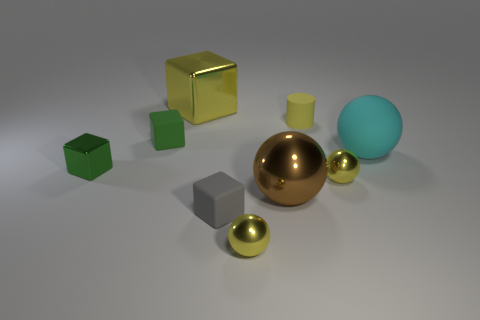Subtract 1 blocks. How many blocks are left? 3 Subtract all cyan spheres. How many spheres are left? 3 Subtract all large cyan spheres. How many spheres are left? 3 Subtract all purple cubes. Subtract all red cylinders. How many cubes are left? 4 Add 1 tiny yellow matte objects. How many objects exist? 10 Subtract all cylinders. How many objects are left? 8 Add 6 gray objects. How many gray objects exist? 7 Subtract 0 red spheres. How many objects are left? 9 Subtract all small yellow shiny spheres. Subtract all rubber cylinders. How many objects are left? 6 Add 9 brown objects. How many brown objects are left? 10 